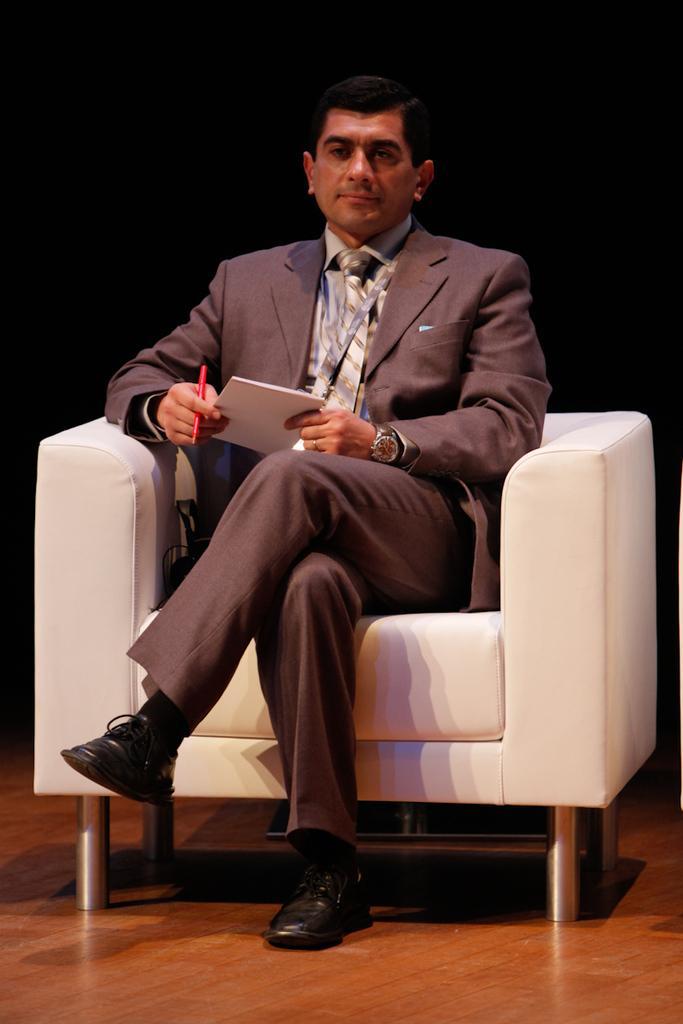In one or two sentences, can you explain what this image depicts? In the middle of the image a person is sitting on a chair and holding a book and pen. 